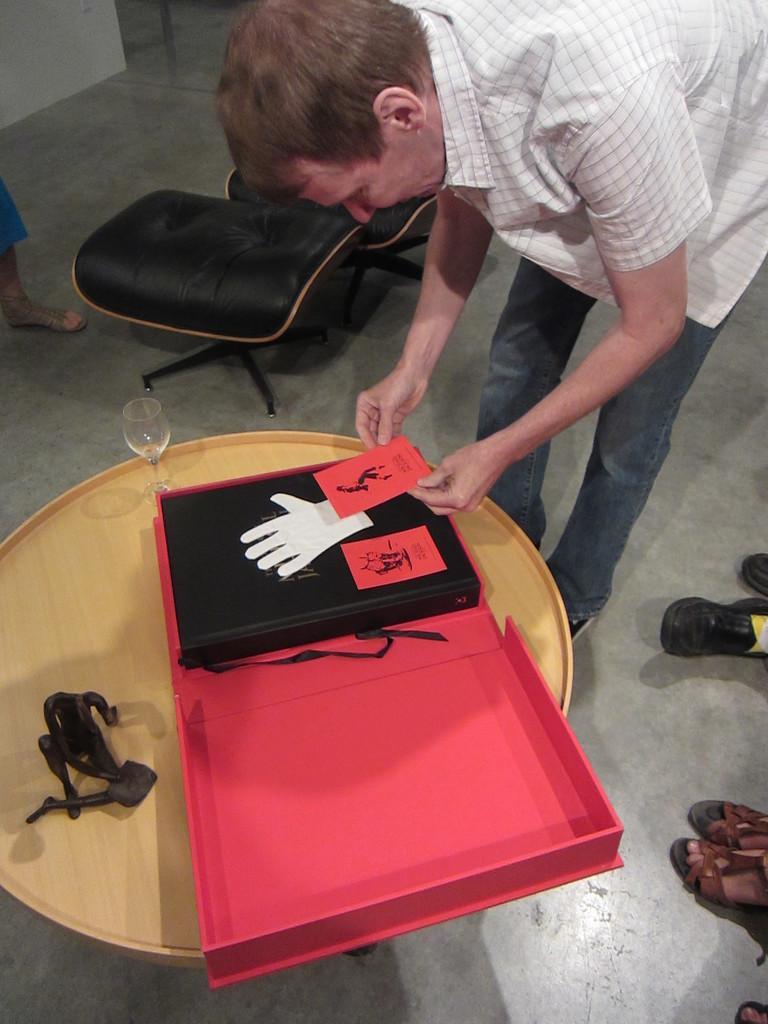Please provide a concise description of this image. This is the man standing and holding red color card on his hands. This is a wooden table with a wine glass,a book,and and object placed on the table. This looks like a chair. At the right corner of the image I can see footwear of person. 